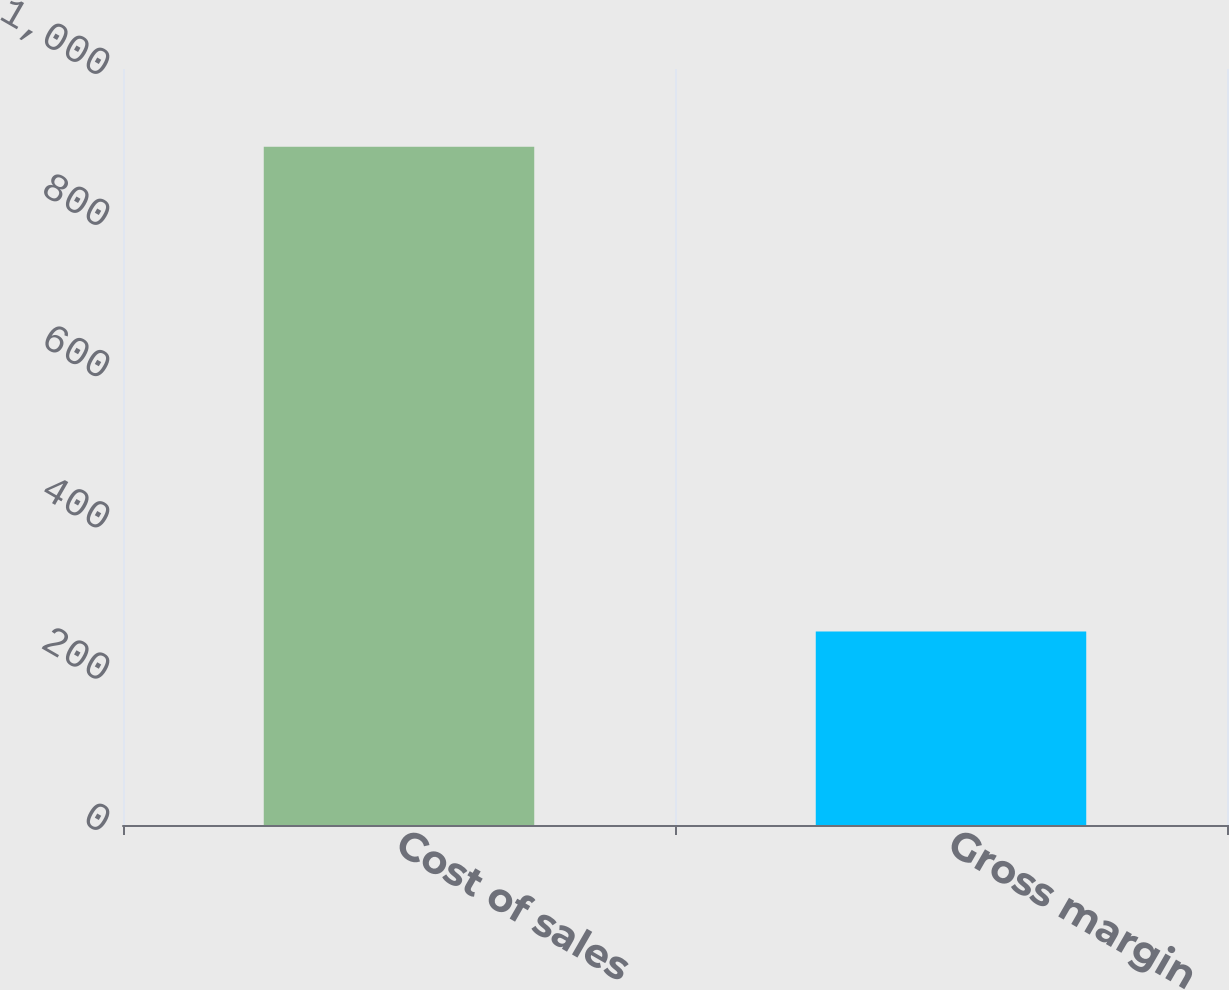<chart> <loc_0><loc_0><loc_500><loc_500><bar_chart><fcel>Cost of sales<fcel>Gross margin<nl><fcel>897<fcel>256<nl></chart> 